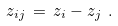Convert formula to latex. <formula><loc_0><loc_0><loc_500><loc_500>z _ { i j } \, = \, z _ { i } - z _ { j } \ .</formula> 